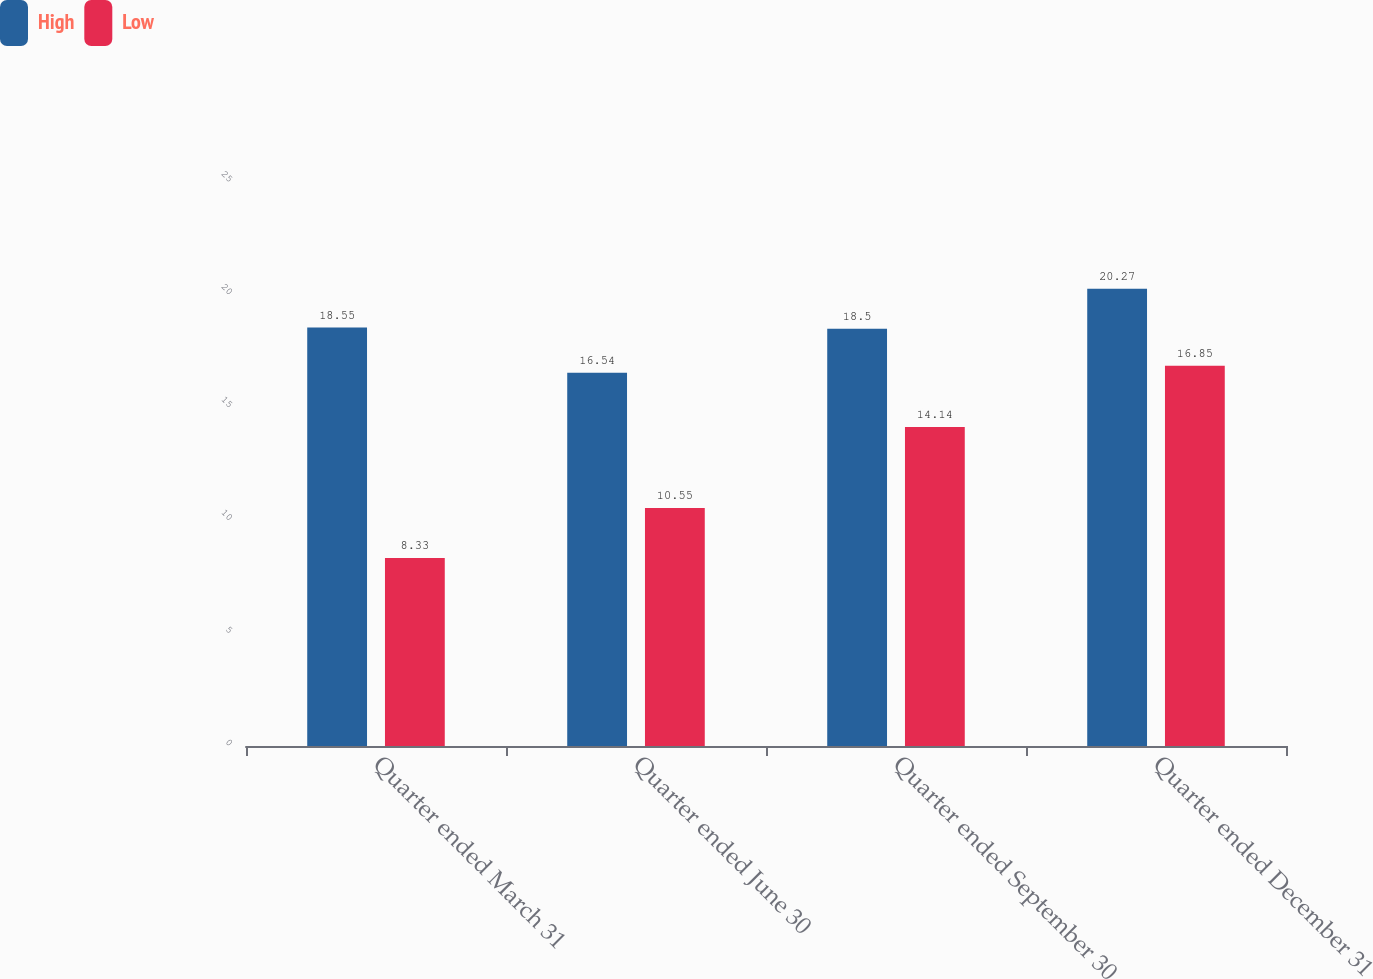Convert chart. <chart><loc_0><loc_0><loc_500><loc_500><stacked_bar_chart><ecel><fcel>Quarter ended March 31<fcel>Quarter ended June 30<fcel>Quarter ended September 30<fcel>Quarter ended December 31<nl><fcel>High<fcel>18.55<fcel>16.54<fcel>18.5<fcel>20.27<nl><fcel>Low<fcel>8.33<fcel>10.55<fcel>14.14<fcel>16.85<nl></chart> 